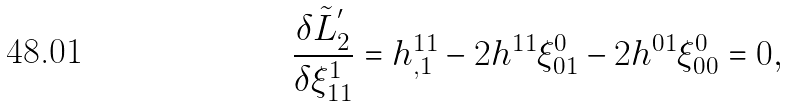Convert formula to latex. <formula><loc_0><loc_0><loc_500><loc_500>\frac { \delta \tilde { L } _ { 2 } ^ { ^ { \prime } } } { \delta \xi _ { 1 1 } ^ { 1 } } = h _ { , 1 } ^ { 1 1 } - 2 h ^ { 1 1 } \xi _ { 0 1 } ^ { 0 } - 2 h ^ { 0 1 } \xi _ { 0 0 } ^ { 0 } = 0 ,</formula> 